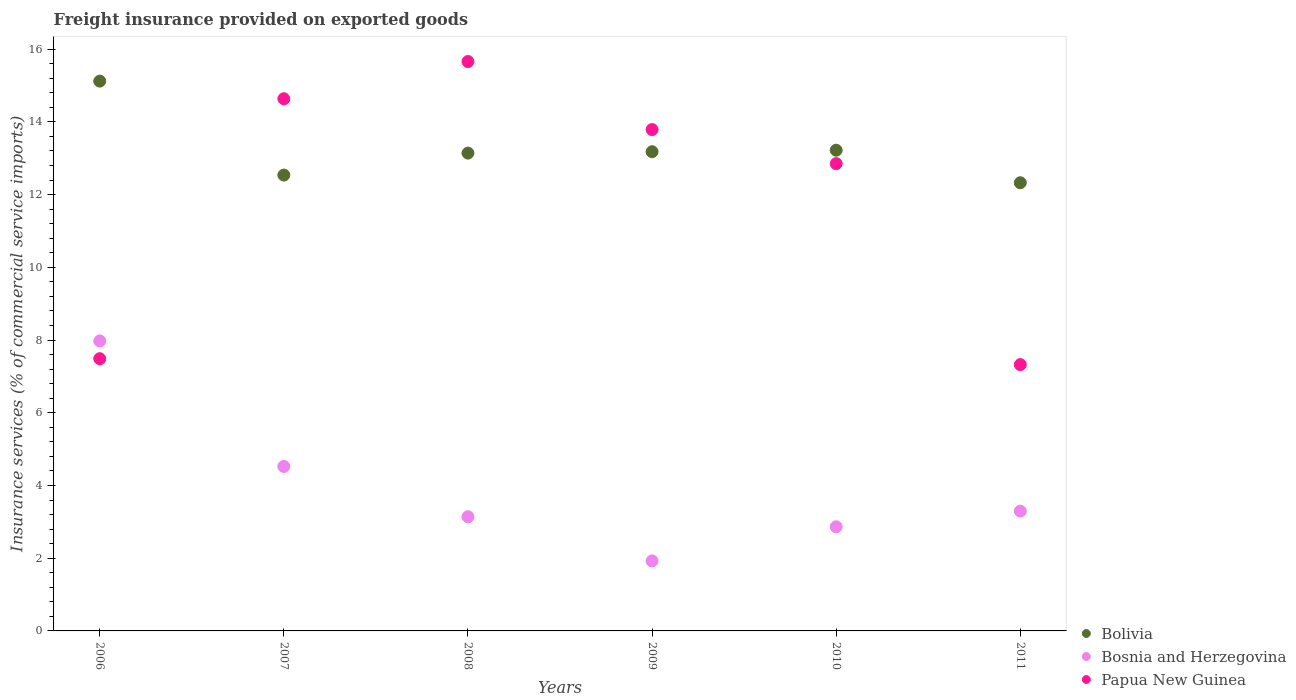How many different coloured dotlines are there?
Offer a very short reply. 3. What is the freight insurance provided on exported goods in Bolivia in 2011?
Make the answer very short. 12.33. Across all years, what is the maximum freight insurance provided on exported goods in Bolivia?
Keep it short and to the point. 15.12. Across all years, what is the minimum freight insurance provided on exported goods in Bolivia?
Your answer should be very brief. 12.33. In which year was the freight insurance provided on exported goods in Papua New Guinea maximum?
Make the answer very short. 2008. What is the total freight insurance provided on exported goods in Bolivia in the graph?
Your answer should be very brief. 79.53. What is the difference between the freight insurance provided on exported goods in Bolivia in 2008 and that in 2009?
Provide a short and direct response. -0.04. What is the difference between the freight insurance provided on exported goods in Bosnia and Herzegovina in 2010 and the freight insurance provided on exported goods in Papua New Guinea in 2008?
Provide a succinct answer. -12.8. What is the average freight insurance provided on exported goods in Bolivia per year?
Offer a very short reply. 13.25. In the year 2006, what is the difference between the freight insurance provided on exported goods in Papua New Guinea and freight insurance provided on exported goods in Bolivia?
Provide a succinct answer. -7.63. In how many years, is the freight insurance provided on exported goods in Papua New Guinea greater than 7.6 %?
Give a very brief answer. 4. What is the ratio of the freight insurance provided on exported goods in Papua New Guinea in 2008 to that in 2009?
Your answer should be compact. 1.14. Is the freight insurance provided on exported goods in Papua New Guinea in 2009 less than that in 2010?
Your answer should be compact. No. What is the difference between the highest and the second highest freight insurance provided on exported goods in Bolivia?
Keep it short and to the point. 1.9. What is the difference between the highest and the lowest freight insurance provided on exported goods in Bosnia and Herzegovina?
Offer a very short reply. 6.05. In how many years, is the freight insurance provided on exported goods in Bolivia greater than the average freight insurance provided on exported goods in Bolivia taken over all years?
Ensure brevity in your answer.  1. Is the sum of the freight insurance provided on exported goods in Papua New Guinea in 2009 and 2011 greater than the maximum freight insurance provided on exported goods in Bolivia across all years?
Your answer should be very brief. Yes. Is it the case that in every year, the sum of the freight insurance provided on exported goods in Bosnia and Herzegovina and freight insurance provided on exported goods in Bolivia  is greater than the freight insurance provided on exported goods in Papua New Guinea?
Provide a short and direct response. Yes. Does the freight insurance provided on exported goods in Bolivia monotonically increase over the years?
Ensure brevity in your answer.  No. How many dotlines are there?
Offer a very short reply. 3. How many years are there in the graph?
Keep it short and to the point. 6. Does the graph contain any zero values?
Provide a succinct answer. No. Does the graph contain grids?
Your answer should be very brief. No. How are the legend labels stacked?
Give a very brief answer. Vertical. What is the title of the graph?
Your answer should be very brief. Freight insurance provided on exported goods. What is the label or title of the Y-axis?
Give a very brief answer. Insurance services (% of commercial service imports). What is the Insurance services (% of commercial service imports) in Bolivia in 2006?
Make the answer very short. 15.12. What is the Insurance services (% of commercial service imports) of Bosnia and Herzegovina in 2006?
Ensure brevity in your answer.  7.98. What is the Insurance services (% of commercial service imports) of Papua New Guinea in 2006?
Your answer should be very brief. 7.49. What is the Insurance services (% of commercial service imports) of Bolivia in 2007?
Your answer should be compact. 12.54. What is the Insurance services (% of commercial service imports) in Bosnia and Herzegovina in 2007?
Offer a terse response. 4.52. What is the Insurance services (% of commercial service imports) in Papua New Guinea in 2007?
Offer a very short reply. 14.64. What is the Insurance services (% of commercial service imports) in Bolivia in 2008?
Your answer should be very brief. 13.14. What is the Insurance services (% of commercial service imports) of Bosnia and Herzegovina in 2008?
Provide a succinct answer. 3.14. What is the Insurance services (% of commercial service imports) in Papua New Guinea in 2008?
Provide a succinct answer. 15.66. What is the Insurance services (% of commercial service imports) of Bolivia in 2009?
Offer a very short reply. 13.18. What is the Insurance services (% of commercial service imports) in Bosnia and Herzegovina in 2009?
Your answer should be very brief. 1.93. What is the Insurance services (% of commercial service imports) of Papua New Guinea in 2009?
Your answer should be compact. 13.79. What is the Insurance services (% of commercial service imports) of Bolivia in 2010?
Make the answer very short. 13.22. What is the Insurance services (% of commercial service imports) in Bosnia and Herzegovina in 2010?
Ensure brevity in your answer.  2.86. What is the Insurance services (% of commercial service imports) of Papua New Guinea in 2010?
Keep it short and to the point. 12.85. What is the Insurance services (% of commercial service imports) in Bolivia in 2011?
Make the answer very short. 12.33. What is the Insurance services (% of commercial service imports) of Bosnia and Herzegovina in 2011?
Offer a terse response. 3.29. What is the Insurance services (% of commercial service imports) in Papua New Guinea in 2011?
Offer a terse response. 7.32. Across all years, what is the maximum Insurance services (% of commercial service imports) in Bolivia?
Provide a short and direct response. 15.12. Across all years, what is the maximum Insurance services (% of commercial service imports) in Bosnia and Herzegovina?
Provide a succinct answer. 7.98. Across all years, what is the maximum Insurance services (% of commercial service imports) of Papua New Guinea?
Make the answer very short. 15.66. Across all years, what is the minimum Insurance services (% of commercial service imports) of Bolivia?
Your answer should be very brief. 12.33. Across all years, what is the minimum Insurance services (% of commercial service imports) of Bosnia and Herzegovina?
Give a very brief answer. 1.93. Across all years, what is the minimum Insurance services (% of commercial service imports) of Papua New Guinea?
Keep it short and to the point. 7.32. What is the total Insurance services (% of commercial service imports) in Bolivia in the graph?
Keep it short and to the point. 79.53. What is the total Insurance services (% of commercial service imports) of Bosnia and Herzegovina in the graph?
Provide a succinct answer. 23.72. What is the total Insurance services (% of commercial service imports) of Papua New Guinea in the graph?
Offer a terse response. 71.75. What is the difference between the Insurance services (% of commercial service imports) in Bolivia in 2006 and that in 2007?
Offer a very short reply. 2.58. What is the difference between the Insurance services (% of commercial service imports) of Bosnia and Herzegovina in 2006 and that in 2007?
Offer a very short reply. 3.45. What is the difference between the Insurance services (% of commercial service imports) in Papua New Guinea in 2006 and that in 2007?
Offer a very short reply. -7.15. What is the difference between the Insurance services (% of commercial service imports) of Bolivia in 2006 and that in 2008?
Your answer should be very brief. 1.98. What is the difference between the Insurance services (% of commercial service imports) in Bosnia and Herzegovina in 2006 and that in 2008?
Make the answer very short. 4.84. What is the difference between the Insurance services (% of commercial service imports) in Papua New Guinea in 2006 and that in 2008?
Offer a terse response. -8.17. What is the difference between the Insurance services (% of commercial service imports) of Bolivia in 2006 and that in 2009?
Ensure brevity in your answer.  1.94. What is the difference between the Insurance services (% of commercial service imports) in Bosnia and Herzegovina in 2006 and that in 2009?
Make the answer very short. 6.05. What is the difference between the Insurance services (% of commercial service imports) in Papua New Guinea in 2006 and that in 2009?
Provide a succinct answer. -6.3. What is the difference between the Insurance services (% of commercial service imports) of Bolivia in 2006 and that in 2010?
Offer a very short reply. 1.9. What is the difference between the Insurance services (% of commercial service imports) of Bosnia and Herzegovina in 2006 and that in 2010?
Offer a terse response. 5.11. What is the difference between the Insurance services (% of commercial service imports) in Papua New Guinea in 2006 and that in 2010?
Provide a short and direct response. -5.36. What is the difference between the Insurance services (% of commercial service imports) of Bolivia in 2006 and that in 2011?
Ensure brevity in your answer.  2.79. What is the difference between the Insurance services (% of commercial service imports) in Bosnia and Herzegovina in 2006 and that in 2011?
Provide a short and direct response. 4.68. What is the difference between the Insurance services (% of commercial service imports) of Papua New Guinea in 2006 and that in 2011?
Your response must be concise. 0.16. What is the difference between the Insurance services (% of commercial service imports) of Bolivia in 2007 and that in 2008?
Offer a very short reply. -0.6. What is the difference between the Insurance services (% of commercial service imports) of Bosnia and Herzegovina in 2007 and that in 2008?
Give a very brief answer. 1.38. What is the difference between the Insurance services (% of commercial service imports) in Papua New Guinea in 2007 and that in 2008?
Provide a short and direct response. -1.02. What is the difference between the Insurance services (% of commercial service imports) of Bolivia in 2007 and that in 2009?
Your response must be concise. -0.64. What is the difference between the Insurance services (% of commercial service imports) in Bosnia and Herzegovina in 2007 and that in 2009?
Your answer should be compact. 2.6. What is the difference between the Insurance services (% of commercial service imports) of Papua New Guinea in 2007 and that in 2009?
Provide a succinct answer. 0.85. What is the difference between the Insurance services (% of commercial service imports) of Bolivia in 2007 and that in 2010?
Make the answer very short. -0.68. What is the difference between the Insurance services (% of commercial service imports) in Bosnia and Herzegovina in 2007 and that in 2010?
Make the answer very short. 1.66. What is the difference between the Insurance services (% of commercial service imports) of Papua New Guinea in 2007 and that in 2010?
Offer a very short reply. 1.78. What is the difference between the Insurance services (% of commercial service imports) of Bolivia in 2007 and that in 2011?
Make the answer very short. 0.21. What is the difference between the Insurance services (% of commercial service imports) in Bosnia and Herzegovina in 2007 and that in 2011?
Your response must be concise. 1.23. What is the difference between the Insurance services (% of commercial service imports) of Papua New Guinea in 2007 and that in 2011?
Provide a short and direct response. 7.31. What is the difference between the Insurance services (% of commercial service imports) of Bolivia in 2008 and that in 2009?
Make the answer very short. -0.04. What is the difference between the Insurance services (% of commercial service imports) of Bosnia and Herzegovina in 2008 and that in 2009?
Your answer should be compact. 1.21. What is the difference between the Insurance services (% of commercial service imports) of Papua New Guinea in 2008 and that in 2009?
Make the answer very short. 1.87. What is the difference between the Insurance services (% of commercial service imports) of Bolivia in 2008 and that in 2010?
Your answer should be compact. -0.08. What is the difference between the Insurance services (% of commercial service imports) in Bosnia and Herzegovina in 2008 and that in 2010?
Your answer should be compact. 0.28. What is the difference between the Insurance services (% of commercial service imports) in Papua New Guinea in 2008 and that in 2010?
Your answer should be compact. 2.81. What is the difference between the Insurance services (% of commercial service imports) in Bolivia in 2008 and that in 2011?
Your response must be concise. 0.82. What is the difference between the Insurance services (% of commercial service imports) of Bosnia and Herzegovina in 2008 and that in 2011?
Offer a very short reply. -0.15. What is the difference between the Insurance services (% of commercial service imports) of Papua New Guinea in 2008 and that in 2011?
Keep it short and to the point. 8.34. What is the difference between the Insurance services (% of commercial service imports) of Bolivia in 2009 and that in 2010?
Offer a very short reply. -0.04. What is the difference between the Insurance services (% of commercial service imports) in Bosnia and Herzegovina in 2009 and that in 2010?
Make the answer very short. -0.94. What is the difference between the Insurance services (% of commercial service imports) in Papua New Guinea in 2009 and that in 2010?
Your answer should be compact. 0.94. What is the difference between the Insurance services (% of commercial service imports) of Bolivia in 2009 and that in 2011?
Your answer should be compact. 0.85. What is the difference between the Insurance services (% of commercial service imports) of Bosnia and Herzegovina in 2009 and that in 2011?
Your answer should be very brief. -1.37. What is the difference between the Insurance services (% of commercial service imports) of Papua New Guinea in 2009 and that in 2011?
Your answer should be very brief. 6.46. What is the difference between the Insurance services (% of commercial service imports) of Bolivia in 2010 and that in 2011?
Give a very brief answer. 0.89. What is the difference between the Insurance services (% of commercial service imports) of Bosnia and Herzegovina in 2010 and that in 2011?
Keep it short and to the point. -0.43. What is the difference between the Insurance services (% of commercial service imports) of Papua New Guinea in 2010 and that in 2011?
Your response must be concise. 5.53. What is the difference between the Insurance services (% of commercial service imports) in Bolivia in 2006 and the Insurance services (% of commercial service imports) in Bosnia and Herzegovina in 2007?
Provide a short and direct response. 10.6. What is the difference between the Insurance services (% of commercial service imports) of Bolivia in 2006 and the Insurance services (% of commercial service imports) of Papua New Guinea in 2007?
Keep it short and to the point. 0.48. What is the difference between the Insurance services (% of commercial service imports) of Bosnia and Herzegovina in 2006 and the Insurance services (% of commercial service imports) of Papua New Guinea in 2007?
Keep it short and to the point. -6.66. What is the difference between the Insurance services (% of commercial service imports) of Bolivia in 2006 and the Insurance services (% of commercial service imports) of Bosnia and Herzegovina in 2008?
Make the answer very short. 11.98. What is the difference between the Insurance services (% of commercial service imports) in Bolivia in 2006 and the Insurance services (% of commercial service imports) in Papua New Guinea in 2008?
Your answer should be compact. -0.54. What is the difference between the Insurance services (% of commercial service imports) in Bosnia and Herzegovina in 2006 and the Insurance services (% of commercial service imports) in Papua New Guinea in 2008?
Ensure brevity in your answer.  -7.68. What is the difference between the Insurance services (% of commercial service imports) in Bolivia in 2006 and the Insurance services (% of commercial service imports) in Bosnia and Herzegovina in 2009?
Your answer should be compact. 13.2. What is the difference between the Insurance services (% of commercial service imports) in Bolivia in 2006 and the Insurance services (% of commercial service imports) in Papua New Guinea in 2009?
Keep it short and to the point. 1.33. What is the difference between the Insurance services (% of commercial service imports) in Bosnia and Herzegovina in 2006 and the Insurance services (% of commercial service imports) in Papua New Guinea in 2009?
Keep it short and to the point. -5.81. What is the difference between the Insurance services (% of commercial service imports) in Bolivia in 2006 and the Insurance services (% of commercial service imports) in Bosnia and Herzegovina in 2010?
Make the answer very short. 12.26. What is the difference between the Insurance services (% of commercial service imports) in Bolivia in 2006 and the Insurance services (% of commercial service imports) in Papua New Guinea in 2010?
Give a very brief answer. 2.27. What is the difference between the Insurance services (% of commercial service imports) of Bosnia and Herzegovina in 2006 and the Insurance services (% of commercial service imports) of Papua New Guinea in 2010?
Ensure brevity in your answer.  -4.88. What is the difference between the Insurance services (% of commercial service imports) of Bolivia in 2006 and the Insurance services (% of commercial service imports) of Bosnia and Herzegovina in 2011?
Make the answer very short. 11.83. What is the difference between the Insurance services (% of commercial service imports) in Bolivia in 2006 and the Insurance services (% of commercial service imports) in Papua New Guinea in 2011?
Give a very brief answer. 7.8. What is the difference between the Insurance services (% of commercial service imports) in Bosnia and Herzegovina in 2006 and the Insurance services (% of commercial service imports) in Papua New Guinea in 2011?
Provide a succinct answer. 0.65. What is the difference between the Insurance services (% of commercial service imports) in Bolivia in 2007 and the Insurance services (% of commercial service imports) in Bosnia and Herzegovina in 2008?
Ensure brevity in your answer.  9.4. What is the difference between the Insurance services (% of commercial service imports) in Bolivia in 2007 and the Insurance services (% of commercial service imports) in Papua New Guinea in 2008?
Give a very brief answer. -3.12. What is the difference between the Insurance services (% of commercial service imports) of Bosnia and Herzegovina in 2007 and the Insurance services (% of commercial service imports) of Papua New Guinea in 2008?
Offer a terse response. -11.14. What is the difference between the Insurance services (% of commercial service imports) in Bolivia in 2007 and the Insurance services (% of commercial service imports) in Bosnia and Herzegovina in 2009?
Your response must be concise. 10.61. What is the difference between the Insurance services (% of commercial service imports) in Bolivia in 2007 and the Insurance services (% of commercial service imports) in Papua New Guinea in 2009?
Provide a succinct answer. -1.25. What is the difference between the Insurance services (% of commercial service imports) in Bosnia and Herzegovina in 2007 and the Insurance services (% of commercial service imports) in Papua New Guinea in 2009?
Keep it short and to the point. -9.27. What is the difference between the Insurance services (% of commercial service imports) in Bolivia in 2007 and the Insurance services (% of commercial service imports) in Bosnia and Herzegovina in 2010?
Offer a terse response. 9.67. What is the difference between the Insurance services (% of commercial service imports) of Bolivia in 2007 and the Insurance services (% of commercial service imports) of Papua New Guinea in 2010?
Keep it short and to the point. -0.31. What is the difference between the Insurance services (% of commercial service imports) in Bosnia and Herzegovina in 2007 and the Insurance services (% of commercial service imports) in Papua New Guinea in 2010?
Provide a succinct answer. -8.33. What is the difference between the Insurance services (% of commercial service imports) of Bolivia in 2007 and the Insurance services (% of commercial service imports) of Bosnia and Herzegovina in 2011?
Keep it short and to the point. 9.24. What is the difference between the Insurance services (% of commercial service imports) of Bolivia in 2007 and the Insurance services (% of commercial service imports) of Papua New Guinea in 2011?
Ensure brevity in your answer.  5.21. What is the difference between the Insurance services (% of commercial service imports) of Bosnia and Herzegovina in 2007 and the Insurance services (% of commercial service imports) of Papua New Guinea in 2011?
Make the answer very short. -2.8. What is the difference between the Insurance services (% of commercial service imports) of Bolivia in 2008 and the Insurance services (% of commercial service imports) of Bosnia and Herzegovina in 2009?
Your answer should be very brief. 11.22. What is the difference between the Insurance services (% of commercial service imports) of Bolivia in 2008 and the Insurance services (% of commercial service imports) of Papua New Guinea in 2009?
Your answer should be compact. -0.65. What is the difference between the Insurance services (% of commercial service imports) of Bosnia and Herzegovina in 2008 and the Insurance services (% of commercial service imports) of Papua New Guinea in 2009?
Your answer should be compact. -10.65. What is the difference between the Insurance services (% of commercial service imports) of Bolivia in 2008 and the Insurance services (% of commercial service imports) of Bosnia and Herzegovina in 2010?
Offer a terse response. 10.28. What is the difference between the Insurance services (% of commercial service imports) of Bolivia in 2008 and the Insurance services (% of commercial service imports) of Papua New Guinea in 2010?
Your answer should be compact. 0.29. What is the difference between the Insurance services (% of commercial service imports) in Bosnia and Herzegovina in 2008 and the Insurance services (% of commercial service imports) in Papua New Guinea in 2010?
Your answer should be very brief. -9.71. What is the difference between the Insurance services (% of commercial service imports) in Bolivia in 2008 and the Insurance services (% of commercial service imports) in Bosnia and Herzegovina in 2011?
Provide a succinct answer. 9.85. What is the difference between the Insurance services (% of commercial service imports) in Bolivia in 2008 and the Insurance services (% of commercial service imports) in Papua New Guinea in 2011?
Keep it short and to the point. 5.82. What is the difference between the Insurance services (% of commercial service imports) in Bosnia and Herzegovina in 2008 and the Insurance services (% of commercial service imports) in Papua New Guinea in 2011?
Ensure brevity in your answer.  -4.18. What is the difference between the Insurance services (% of commercial service imports) in Bolivia in 2009 and the Insurance services (% of commercial service imports) in Bosnia and Herzegovina in 2010?
Give a very brief answer. 10.32. What is the difference between the Insurance services (% of commercial service imports) in Bolivia in 2009 and the Insurance services (% of commercial service imports) in Papua New Guinea in 2010?
Keep it short and to the point. 0.33. What is the difference between the Insurance services (% of commercial service imports) in Bosnia and Herzegovina in 2009 and the Insurance services (% of commercial service imports) in Papua New Guinea in 2010?
Offer a terse response. -10.93. What is the difference between the Insurance services (% of commercial service imports) in Bolivia in 2009 and the Insurance services (% of commercial service imports) in Bosnia and Herzegovina in 2011?
Provide a succinct answer. 9.89. What is the difference between the Insurance services (% of commercial service imports) in Bolivia in 2009 and the Insurance services (% of commercial service imports) in Papua New Guinea in 2011?
Make the answer very short. 5.86. What is the difference between the Insurance services (% of commercial service imports) of Bosnia and Herzegovina in 2009 and the Insurance services (% of commercial service imports) of Papua New Guinea in 2011?
Your response must be concise. -5.4. What is the difference between the Insurance services (% of commercial service imports) in Bolivia in 2010 and the Insurance services (% of commercial service imports) in Bosnia and Herzegovina in 2011?
Offer a terse response. 9.93. What is the difference between the Insurance services (% of commercial service imports) in Bolivia in 2010 and the Insurance services (% of commercial service imports) in Papua New Guinea in 2011?
Your answer should be very brief. 5.9. What is the difference between the Insurance services (% of commercial service imports) in Bosnia and Herzegovina in 2010 and the Insurance services (% of commercial service imports) in Papua New Guinea in 2011?
Your response must be concise. -4.46. What is the average Insurance services (% of commercial service imports) in Bolivia per year?
Your answer should be compact. 13.25. What is the average Insurance services (% of commercial service imports) in Bosnia and Herzegovina per year?
Your response must be concise. 3.95. What is the average Insurance services (% of commercial service imports) of Papua New Guinea per year?
Make the answer very short. 11.96. In the year 2006, what is the difference between the Insurance services (% of commercial service imports) in Bolivia and Insurance services (% of commercial service imports) in Bosnia and Herzegovina?
Ensure brevity in your answer.  7.15. In the year 2006, what is the difference between the Insurance services (% of commercial service imports) in Bolivia and Insurance services (% of commercial service imports) in Papua New Guinea?
Provide a succinct answer. 7.63. In the year 2006, what is the difference between the Insurance services (% of commercial service imports) in Bosnia and Herzegovina and Insurance services (% of commercial service imports) in Papua New Guinea?
Make the answer very short. 0.49. In the year 2007, what is the difference between the Insurance services (% of commercial service imports) in Bolivia and Insurance services (% of commercial service imports) in Bosnia and Herzegovina?
Offer a terse response. 8.01. In the year 2007, what is the difference between the Insurance services (% of commercial service imports) in Bolivia and Insurance services (% of commercial service imports) in Papua New Guinea?
Your answer should be very brief. -2.1. In the year 2007, what is the difference between the Insurance services (% of commercial service imports) in Bosnia and Herzegovina and Insurance services (% of commercial service imports) in Papua New Guinea?
Offer a very short reply. -10.11. In the year 2008, what is the difference between the Insurance services (% of commercial service imports) of Bolivia and Insurance services (% of commercial service imports) of Bosnia and Herzegovina?
Your answer should be compact. 10. In the year 2008, what is the difference between the Insurance services (% of commercial service imports) of Bolivia and Insurance services (% of commercial service imports) of Papua New Guinea?
Make the answer very short. -2.52. In the year 2008, what is the difference between the Insurance services (% of commercial service imports) of Bosnia and Herzegovina and Insurance services (% of commercial service imports) of Papua New Guinea?
Offer a very short reply. -12.52. In the year 2009, what is the difference between the Insurance services (% of commercial service imports) of Bolivia and Insurance services (% of commercial service imports) of Bosnia and Herzegovina?
Your answer should be very brief. 11.25. In the year 2009, what is the difference between the Insurance services (% of commercial service imports) in Bolivia and Insurance services (% of commercial service imports) in Papua New Guinea?
Your answer should be very brief. -0.61. In the year 2009, what is the difference between the Insurance services (% of commercial service imports) in Bosnia and Herzegovina and Insurance services (% of commercial service imports) in Papua New Guinea?
Offer a terse response. -11.86. In the year 2010, what is the difference between the Insurance services (% of commercial service imports) of Bolivia and Insurance services (% of commercial service imports) of Bosnia and Herzegovina?
Your answer should be compact. 10.36. In the year 2010, what is the difference between the Insurance services (% of commercial service imports) of Bolivia and Insurance services (% of commercial service imports) of Papua New Guinea?
Offer a terse response. 0.37. In the year 2010, what is the difference between the Insurance services (% of commercial service imports) of Bosnia and Herzegovina and Insurance services (% of commercial service imports) of Papua New Guinea?
Offer a terse response. -9.99. In the year 2011, what is the difference between the Insurance services (% of commercial service imports) of Bolivia and Insurance services (% of commercial service imports) of Bosnia and Herzegovina?
Give a very brief answer. 9.03. In the year 2011, what is the difference between the Insurance services (% of commercial service imports) of Bolivia and Insurance services (% of commercial service imports) of Papua New Guinea?
Your answer should be compact. 5. In the year 2011, what is the difference between the Insurance services (% of commercial service imports) of Bosnia and Herzegovina and Insurance services (% of commercial service imports) of Papua New Guinea?
Keep it short and to the point. -4.03. What is the ratio of the Insurance services (% of commercial service imports) in Bolivia in 2006 to that in 2007?
Ensure brevity in your answer.  1.21. What is the ratio of the Insurance services (% of commercial service imports) of Bosnia and Herzegovina in 2006 to that in 2007?
Your response must be concise. 1.76. What is the ratio of the Insurance services (% of commercial service imports) in Papua New Guinea in 2006 to that in 2007?
Offer a very short reply. 0.51. What is the ratio of the Insurance services (% of commercial service imports) in Bolivia in 2006 to that in 2008?
Keep it short and to the point. 1.15. What is the ratio of the Insurance services (% of commercial service imports) in Bosnia and Herzegovina in 2006 to that in 2008?
Your response must be concise. 2.54. What is the ratio of the Insurance services (% of commercial service imports) in Papua New Guinea in 2006 to that in 2008?
Your answer should be very brief. 0.48. What is the ratio of the Insurance services (% of commercial service imports) in Bolivia in 2006 to that in 2009?
Your response must be concise. 1.15. What is the ratio of the Insurance services (% of commercial service imports) of Bosnia and Herzegovina in 2006 to that in 2009?
Ensure brevity in your answer.  4.14. What is the ratio of the Insurance services (% of commercial service imports) in Papua New Guinea in 2006 to that in 2009?
Offer a terse response. 0.54. What is the ratio of the Insurance services (% of commercial service imports) of Bolivia in 2006 to that in 2010?
Your answer should be very brief. 1.14. What is the ratio of the Insurance services (% of commercial service imports) in Bosnia and Herzegovina in 2006 to that in 2010?
Provide a short and direct response. 2.78. What is the ratio of the Insurance services (% of commercial service imports) in Papua New Guinea in 2006 to that in 2010?
Keep it short and to the point. 0.58. What is the ratio of the Insurance services (% of commercial service imports) in Bolivia in 2006 to that in 2011?
Give a very brief answer. 1.23. What is the ratio of the Insurance services (% of commercial service imports) of Bosnia and Herzegovina in 2006 to that in 2011?
Your answer should be compact. 2.42. What is the ratio of the Insurance services (% of commercial service imports) of Papua New Guinea in 2006 to that in 2011?
Your answer should be compact. 1.02. What is the ratio of the Insurance services (% of commercial service imports) of Bolivia in 2007 to that in 2008?
Your response must be concise. 0.95. What is the ratio of the Insurance services (% of commercial service imports) of Bosnia and Herzegovina in 2007 to that in 2008?
Offer a terse response. 1.44. What is the ratio of the Insurance services (% of commercial service imports) of Papua New Guinea in 2007 to that in 2008?
Provide a succinct answer. 0.93. What is the ratio of the Insurance services (% of commercial service imports) in Bolivia in 2007 to that in 2009?
Offer a very short reply. 0.95. What is the ratio of the Insurance services (% of commercial service imports) in Bosnia and Herzegovina in 2007 to that in 2009?
Keep it short and to the point. 2.35. What is the ratio of the Insurance services (% of commercial service imports) of Papua New Guinea in 2007 to that in 2009?
Offer a very short reply. 1.06. What is the ratio of the Insurance services (% of commercial service imports) of Bolivia in 2007 to that in 2010?
Your answer should be compact. 0.95. What is the ratio of the Insurance services (% of commercial service imports) in Bosnia and Herzegovina in 2007 to that in 2010?
Provide a short and direct response. 1.58. What is the ratio of the Insurance services (% of commercial service imports) in Papua New Guinea in 2007 to that in 2010?
Offer a terse response. 1.14. What is the ratio of the Insurance services (% of commercial service imports) in Bolivia in 2007 to that in 2011?
Provide a short and direct response. 1.02. What is the ratio of the Insurance services (% of commercial service imports) of Bosnia and Herzegovina in 2007 to that in 2011?
Your response must be concise. 1.37. What is the ratio of the Insurance services (% of commercial service imports) in Papua New Guinea in 2007 to that in 2011?
Keep it short and to the point. 2. What is the ratio of the Insurance services (% of commercial service imports) in Bosnia and Herzegovina in 2008 to that in 2009?
Provide a short and direct response. 1.63. What is the ratio of the Insurance services (% of commercial service imports) in Papua New Guinea in 2008 to that in 2009?
Make the answer very short. 1.14. What is the ratio of the Insurance services (% of commercial service imports) in Bolivia in 2008 to that in 2010?
Offer a very short reply. 0.99. What is the ratio of the Insurance services (% of commercial service imports) of Bosnia and Herzegovina in 2008 to that in 2010?
Provide a succinct answer. 1.1. What is the ratio of the Insurance services (% of commercial service imports) in Papua New Guinea in 2008 to that in 2010?
Offer a terse response. 1.22. What is the ratio of the Insurance services (% of commercial service imports) of Bolivia in 2008 to that in 2011?
Provide a succinct answer. 1.07. What is the ratio of the Insurance services (% of commercial service imports) of Bosnia and Herzegovina in 2008 to that in 2011?
Your response must be concise. 0.95. What is the ratio of the Insurance services (% of commercial service imports) of Papua New Guinea in 2008 to that in 2011?
Ensure brevity in your answer.  2.14. What is the ratio of the Insurance services (% of commercial service imports) in Bosnia and Herzegovina in 2009 to that in 2010?
Make the answer very short. 0.67. What is the ratio of the Insurance services (% of commercial service imports) of Papua New Guinea in 2009 to that in 2010?
Offer a terse response. 1.07. What is the ratio of the Insurance services (% of commercial service imports) of Bolivia in 2009 to that in 2011?
Give a very brief answer. 1.07. What is the ratio of the Insurance services (% of commercial service imports) in Bosnia and Herzegovina in 2009 to that in 2011?
Make the answer very short. 0.58. What is the ratio of the Insurance services (% of commercial service imports) of Papua New Guinea in 2009 to that in 2011?
Ensure brevity in your answer.  1.88. What is the ratio of the Insurance services (% of commercial service imports) in Bolivia in 2010 to that in 2011?
Give a very brief answer. 1.07. What is the ratio of the Insurance services (% of commercial service imports) in Bosnia and Herzegovina in 2010 to that in 2011?
Offer a terse response. 0.87. What is the ratio of the Insurance services (% of commercial service imports) in Papua New Guinea in 2010 to that in 2011?
Your answer should be compact. 1.75. What is the difference between the highest and the second highest Insurance services (% of commercial service imports) in Bolivia?
Make the answer very short. 1.9. What is the difference between the highest and the second highest Insurance services (% of commercial service imports) of Bosnia and Herzegovina?
Offer a very short reply. 3.45. What is the difference between the highest and the second highest Insurance services (% of commercial service imports) in Papua New Guinea?
Keep it short and to the point. 1.02. What is the difference between the highest and the lowest Insurance services (% of commercial service imports) of Bolivia?
Your response must be concise. 2.79. What is the difference between the highest and the lowest Insurance services (% of commercial service imports) in Bosnia and Herzegovina?
Make the answer very short. 6.05. What is the difference between the highest and the lowest Insurance services (% of commercial service imports) of Papua New Guinea?
Your response must be concise. 8.34. 